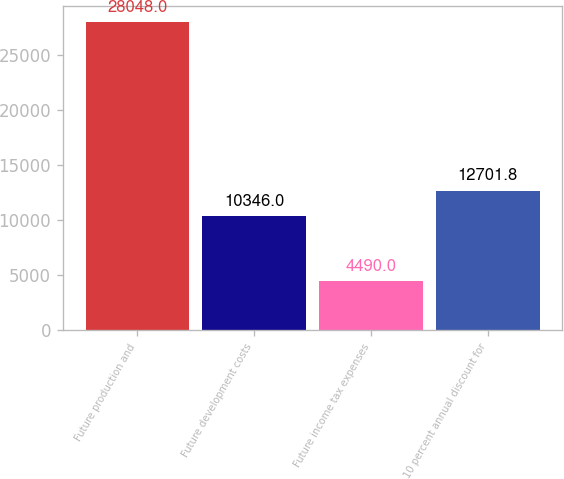Convert chart. <chart><loc_0><loc_0><loc_500><loc_500><bar_chart><fcel>Future production and<fcel>Future development costs<fcel>Future income tax expenses<fcel>10 percent annual discount for<nl><fcel>28048<fcel>10346<fcel>4490<fcel>12701.8<nl></chart> 